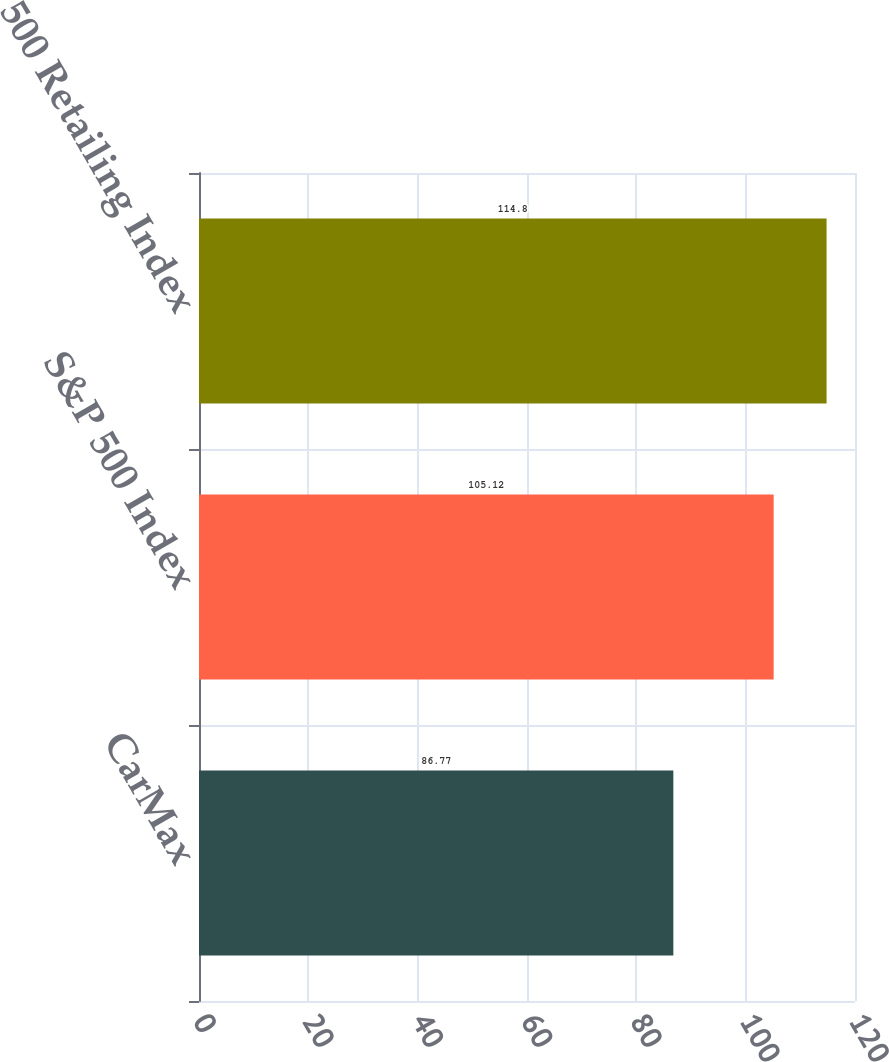Convert chart to OTSL. <chart><loc_0><loc_0><loc_500><loc_500><bar_chart><fcel>CarMax<fcel>S&P 500 Index<fcel>S&P 500 Retailing Index<nl><fcel>86.77<fcel>105.12<fcel>114.8<nl></chart> 